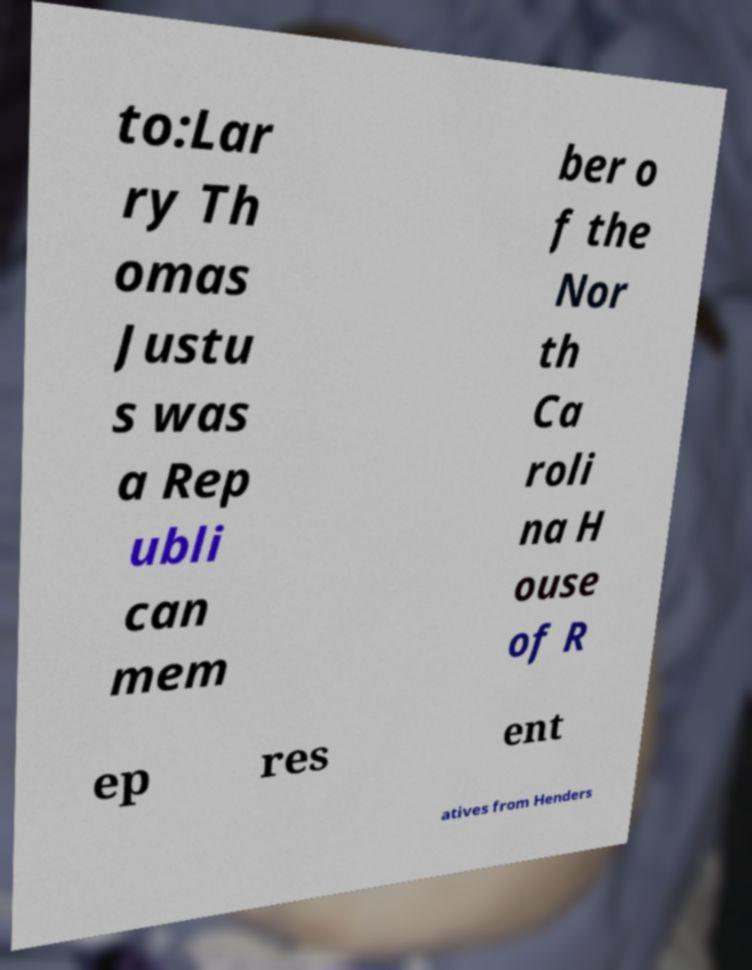For documentation purposes, I need the text within this image transcribed. Could you provide that? to:Lar ry Th omas Justu s was a Rep ubli can mem ber o f the Nor th Ca roli na H ouse of R ep res ent atives from Henders 